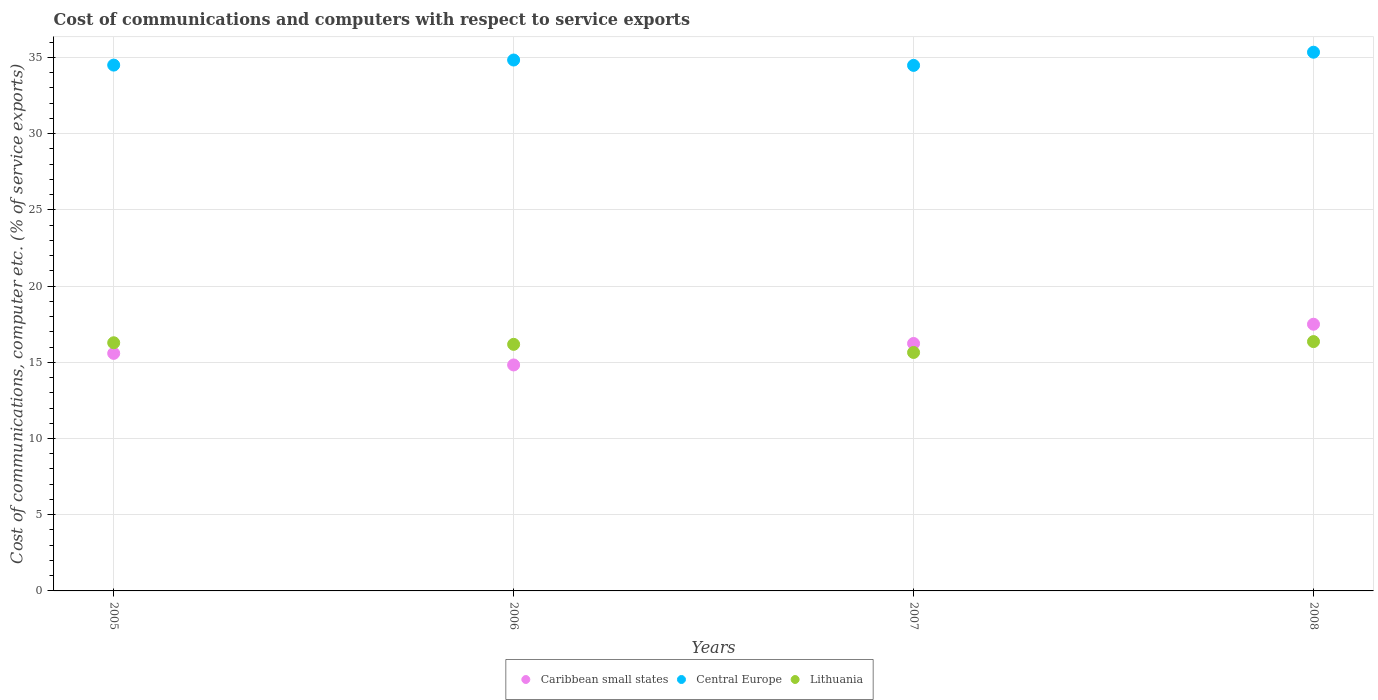How many different coloured dotlines are there?
Give a very brief answer. 3. Is the number of dotlines equal to the number of legend labels?
Offer a very short reply. Yes. What is the cost of communications and computers in Lithuania in 2005?
Offer a very short reply. 16.28. Across all years, what is the maximum cost of communications and computers in Caribbean small states?
Your answer should be very brief. 17.5. Across all years, what is the minimum cost of communications and computers in Caribbean small states?
Provide a short and direct response. 14.82. In which year was the cost of communications and computers in Caribbean small states maximum?
Provide a short and direct response. 2008. In which year was the cost of communications and computers in Central Europe minimum?
Offer a terse response. 2007. What is the total cost of communications and computers in Central Europe in the graph?
Make the answer very short. 139.14. What is the difference between the cost of communications and computers in Central Europe in 2006 and that in 2007?
Your answer should be compact. 0.35. What is the difference between the cost of communications and computers in Caribbean small states in 2006 and the cost of communications and computers in Lithuania in 2005?
Provide a short and direct response. -1.46. What is the average cost of communications and computers in Central Europe per year?
Provide a succinct answer. 34.79. In the year 2007, what is the difference between the cost of communications and computers in Lithuania and cost of communications and computers in Central Europe?
Your answer should be compact. -18.83. In how many years, is the cost of communications and computers in Caribbean small states greater than 30 %?
Your answer should be compact. 0. What is the ratio of the cost of communications and computers in Lithuania in 2006 to that in 2007?
Keep it short and to the point. 1.03. Is the cost of communications and computers in Central Europe in 2005 less than that in 2006?
Offer a very short reply. Yes. Is the difference between the cost of communications and computers in Lithuania in 2007 and 2008 greater than the difference between the cost of communications and computers in Central Europe in 2007 and 2008?
Provide a succinct answer. Yes. What is the difference between the highest and the second highest cost of communications and computers in Central Europe?
Keep it short and to the point. 0.51. What is the difference between the highest and the lowest cost of communications and computers in Caribbean small states?
Your response must be concise. 2.67. In how many years, is the cost of communications and computers in Central Europe greater than the average cost of communications and computers in Central Europe taken over all years?
Make the answer very short. 2. Is the cost of communications and computers in Lithuania strictly greater than the cost of communications and computers in Central Europe over the years?
Your answer should be very brief. No. How many dotlines are there?
Your response must be concise. 3. How many years are there in the graph?
Make the answer very short. 4. Does the graph contain any zero values?
Your answer should be compact. No. Does the graph contain grids?
Keep it short and to the point. Yes. What is the title of the graph?
Provide a short and direct response. Cost of communications and computers with respect to service exports. Does "Chad" appear as one of the legend labels in the graph?
Provide a short and direct response. No. What is the label or title of the X-axis?
Provide a succinct answer. Years. What is the label or title of the Y-axis?
Your response must be concise. Cost of communications, computer etc. (% of service exports). What is the Cost of communications, computer etc. (% of service exports) in Caribbean small states in 2005?
Your answer should be compact. 15.58. What is the Cost of communications, computer etc. (% of service exports) of Central Europe in 2005?
Offer a terse response. 34.5. What is the Cost of communications, computer etc. (% of service exports) of Lithuania in 2005?
Ensure brevity in your answer.  16.28. What is the Cost of communications, computer etc. (% of service exports) of Caribbean small states in 2006?
Your answer should be compact. 14.82. What is the Cost of communications, computer etc. (% of service exports) in Central Europe in 2006?
Ensure brevity in your answer.  34.83. What is the Cost of communications, computer etc. (% of service exports) in Lithuania in 2006?
Give a very brief answer. 16.18. What is the Cost of communications, computer etc. (% of service exports) of Caribbean small states in 2007?
Your response must be concise. 16.23. What is the Cost of communications, computer etc. (% of service exports) of Central Europe in 2007?
Provide a short and direct response. 34.48. What is the Cost of communications, computer etc. (% of service exports) in Lithuania in 2007?
Offer a terse response. 15.64. What is the Cost of communications, computer etc. (% of service exports) in Caribbean small states in 2008?
Your answer should be compact. 17.5. What is the Cost of communications, computer etc. (% of service exports) in Central Europe in 2008?
Give a very brief answer. 35.34. What is the Cost of communications, computer etc. (% of service exports) in Lithuania in 2008?
Provide a short and direct response. 16.36. Across all years, what is the maximum Cost of communications, computer etc. (% of service exports) of Caribbean small states?
Provide a short and direct response. 17.5. Across all years, what is the maximum Cost of communications, computer etc. (% of service exports) of Central Europe?
Offer a terse response. 35.34. Across all years, what is the maximum Cost of communications, computer etc. (% of service exports) in Lithuania?
Provide a succinct answer. 16.36. Across all years, what is the minimum Cost of communications, computer etc. (% of service exports) in Caribbean small states?
Keep it short and to the point. 14.82. Across all years, what is the minimum Cost of communications, computer etc. (% of service exports) of Central Europe?
Your answer should be compact. 34.48. Across all years, what is the minimum Cost of communications, computer etc. (% of service exports) in Lithuania?
Your answer should be compact. 15.64. What is the total Cost of communications, computer etc. (% of service exports) of Caribbean small states in the graph?
Keep it short and to the point. 64.14. What is the total Cost of communications, computer etc. (% of service exports) in Central Europe in the graph?
Your response must be concise. 139.14. What is the total Cost of communications, computer etc. (% of service exports) of Lithuania in the graph?
Offer a terse response. 64.46. What is the difference between the Cost of communications, computer etc. (% of service exports) in Caribbean small states in 2005 and that in 2006?
Your response must be concise. 0.76. What is the difference between the Cost of communications, computer etc. (% of service exports) of Central Europe in 2005 and that in 2006?
Ensure brevity in your answer.  -0.33. What is the difference between the Cost of communications, computer etc. (% of service exports) in Lithuania in 2005 and that in 2006?
Your response must be concise. 0.1. What is the difference between the Cost of communications, computer etc. (% of service exports) in Caribbean small states in 2005 and that in 2007?
Your response must be concise. -0.65. What is the difference between the Cost of communications, computer etc. (% of service exports) in Central Europe in 2005 and that in 2007?
Provide a short and direct response. 0.02. What is the difference between the Cost of communications, computer etc. (% of service exports) of Lithuania in 2005 and that in 2007?
Your answer should be compact. 0.64. What is the difference between the Cost of communications, computer etc. (% of service exports) of Caribbean small states in 2005 and that in 2008?
Offer a very short reply. -1.91. What is the difference between the Cost of communications, computer etc. (% of service exports) of Central Europe in 2005 and that in 2008?
Your response must be concise. -0.85. What is the difference between the Cost of communications, computer etc. (% of service exports) of Lithuania in 2005 and that in 2008?
Offer a terse response. -0.08. What is the difference between the Cost of communications, computer etc. (% of service exports) of Caribbean small states in 2006 and that in 2007?
Provide a succinct answer. -1.41. What is the difference between the Cost of communications, computer etc. (% of service exports) in Central Europe in 2006 and that in 2007?
Offer a terse response. 0.35. What is the difference between the Cost of communications, computer etc. (% of service exports) of Lithuania in 2006 and that in 2007?
Offer a terse response. 0.53. What is the difference between the Cost of communications, computer etc. (% of service exports) in Caribbean small states in 2006 and that in 2008?
Make the answer very short. -2.67. What is the difference between the Cost of communications, computer etc. (% of service exports) in Central Europe in 2006 and that in 2008?
Your response must be concise. -0.51. What is the difference between the Cost of communications, computer etc. (% of service exports) of Lithuania in 2006 and that in 2008?
Your answer should be very brief. -0.18. What is the difference between the Cost of communications, computer etc. (% of service exports) of Caribbean small states in 2007 and that in 2008?
Your answer should be very brief. -1.26. What is the difference between the Cost of communications, computer etc. (% of service exports) of Central Europe in 2007 and that in 2008?
Provide a short and direct response. -0.86. What is the difference between the Cost of communications, computer etc. (% of service exports) in Lithuania in 2007 and that in 2008?
Your response must be concise. -0.71. What is the difference between the Cost of communications, computer etc. (% of service exports) in Caribbean small states in 2005 and the Cost of communications, computer etc. (% of service exports) in Central Europe in 2006?
Provide a succinct answer. -19.24. What is the difference between the Cost of communications, computer etc. (% of service exports) of Caribbean small states in 2005 and the Cost of communications, computer etc. (% of service exports) of Lithuania in 2006?
Offer a terse response. -0.59. What is the difference between the Cost of communications, computer etc. (% of service exports) of Central Europe in 2005 and the Cost of communications, computer etc. (% of service exports) of Lithuania in 2006?
Your response must be concise. 18.32. What is the difference between the Cost of communications, computer etc. (% of service exports) of Caribbean small states in 2005 and the Cost of communications, computer etc. (% of service exports) of Central Europe in 2007?
Your answer should be compact. -18.89. What is the difference between the Cost of communications, computer etc. (% of service exports) in Caribbean small states in 2005 and the Cost of communications, computer etc. (% of service exports) in Lithuania in 2007?
Keep it short and to the point. -0.06. What is the difference between the Cost of communications, computer etc. (% of service exports) in Central Europe in 2005 and the Cost of communications, computer etc. (% of service exports) in Lithuania in 2007?
Ensure brevity in your answer.  18.85. What is the difference between the Cost of communications, computer etc. (% of service exports) of Caribbean small states in 2005 and the Cost of communications, computer etc. (% of service exports) of Central Europe in 2008?
Provide a succinct answer. -19.76. What is the difference between the Cost of communications, computer etc. (% of service exports) in Caribbean small states in 2005 and the Cost of communications, computer etc. (% of service exports) in Lithuania in 2008?
Make the answer very short. -0.77. What is the difference between the Cost of communications, computer etc. (% of service exports) of Central Europe in 2005 and the Cost of communications, computer etc. (% of service exports) of Lithuania in 2008?
Keep it short and to the point. 18.14. What is the difference between the Cost of communications, computer etc. (% of service exports) of Caribbean small states in 2006 and the Cost of communications, computer etc. (% of service exports) of Central Europe in 2007?
Ensure brevity in your answer.  -19.65. What is the difference between the Cost of communications, computer etc. (% of service exports) in Caribbean small states in 2006 and the Cost of communications, computer etc. (% of service exports) in Lithuania in 2007?
Your answer should be compact. -0.82. What is the difference between the Cost of communications, computer etc. (% of service exports) in Central Europe in 2006 and the Cost of communications, computer etc. (% of service exports) in Lithuania in 2007?
Your answer should be compact. 19.19. What is the difference between the Cost of communications, computer etc. (% of service exports) in Caribbean small states in 2006 and the Cost of communications, computer etc. (% of service exports) in Central Europe in 2008?
Your response must be concise. -20.52. What is the difference between the Cost of communications, computer etc. (% of service exports) of Caribbean small states in 2006 and the Cost of communications, computer etc. (% of service exports) of Lithuania in 2008?
Provide a succinct answer. -1.53. What is the difference between the Cost of communications, computer etc. (% of service exports) in Central Europe in 2006 and the Cost of communications, computer etc. (% of service exports) in Lithuania in 2008?
Offer a terse response. 18.47. What is the difference between the Cost of communications, computer etc. (% of service exports) in Caribbean small states in 2007 and the Cost of communications, computer etc. (% of service exports) in Central Europe in 2008?
Offer a terse response. -19.11. What is the difference between the Cost of communications, computer etc. (% of service exports) of Caribbean small states in 2007 and the Cost of communications, computer etc. (% of service exports) of Lithuania in 2008?
Ensure brevity in your answer.  -0.12. What is the difference between the Cost of communications, computer etc. (% of service exports) of Central Europe in 2007 and the Cost of communications, computer etc. (% of service exports) of Lithuania in 2008?
Your response must be concise. 18.12. What is the average Cost of communications, computer etc. (% of service exports) in Caribbean small states per year?
Offer a very short reply. 16.03. What is the average Cost of communications, computer etc. (% of service exports) in Central Europe per year?
Your answer should be very brief. 34.79. What is the average Cost of communications, computer etc. (% of service exports) in Lithuania per year?
Make the answer very short. 16.11. In the year 2005, what is the difference between the Cost of communications, computer etc. (% of service exports) in Caribbean small states and Cost of communications, computer etc. (% of service exports) in Central Europe?
Give a very brief answer. -18.91. In the year 2005, what is the difference between the Cost of communications, computer etc. (% of service exports) in Caribbean small states and Cost of communications, computer etc. (% of service exports) in Lithuania?
Provide a short and direct response. -0.7. In the year 2005, what is the difference between the Cost of communications, computer etc. (% of service exports) in Central Europe and Cost of communications, computer etc. (% of service exports) in Lithuania?
Offer a very short reply. 18.22. In the year 2006, what is the difference between the Cost of communications, computer etc. (% of service exports) in Caribbean small states and Cost of communications, computer etc. (% of service exports) in Central Europe?
Give a very brief answer. -20. In the year 2006, what is the difference between the Cost of communications, computer etc. (% of service exports) in Caribbean small states and Cost of communications, computer etc. (% of service exports) in Lithuania?
Give a very brief answer. -1.35. In the year 2006, what is the difference between the Cost of communications, computer etc. (% of service exports) in Central Europe and Cost of communications, computer etc. (% of service exports) in Lithuania?
Keep it short and to the point. 18.65. In the year 2007, what is the difference between the Cost of communications, computer etc. (% of service exports) of Caribbean small states and Cost of communications, computer etc. (% of service exports) of Central Europe?
Offer a very short reply. -18.24. In the year 2007, what is the difference between the Cost of communications, computer etc. (% of service exports) of Caribbean small states and Cost of communications, computer etc. (% of service exports) of Lithuania?
Make the answer very short. 0.59. In the year 2007, what is the difference between the Cost of communications, computer etc. (% of service exports) of Central Europe and Cost of communications, computer etc. (% of service exports) of Lithuania?
Provide a succinct answer. 18.83. In the year 2008, what is the difference between the Cost of communications, computer etc. (% of service exports) in Caribbean small states and Cost of communications, computer etc. (% of service exports) in Central Europe?
Provide a succinct answer. -17.84. In the year 2008, what is the difference between the Cost of communications, computer etc. (% of service exports) of Caribbean small states and Cost of communications, computer etc. (% of service exports) of Lithuania?
Your response must be concise. 1.14. In the year 2008, what is the difference between the Cost of communications, computer etc. (% of service exports) in Central Europe and Cost of communications, computer etc. (% of service exports) in Lithuania?
Provide a succinct answer. 18.98. What is the ratio of the Cost of communications, computer etc. (% of service exports) of Caribbean small states in 2005 to that in 2006?
Provide a succinct answer. 1.05. What is the ratio of the Cost of communications, computer etc. (% of service exports) in Central Europe in 2005 to that in 2006?
Your response must be concise. 0.99. What is the ratio of the Cost of communications, computer etc. (% of service exports) in Lithuania in 2005 to that in 2006?
Keep it short and to the point. 1.01. What is the ratio of the Cost of communications, computer etc. (% of service exports) of Caribbean small states in 2005 to that in 2007?
Your response must be concise. 0.96. What is the ratio of the Cost of communications, computer etc. (% of service exports) in Central Europe in 2005 to that in 2007?
Ensure brevity in your answer.  1. What is the ratio of the Cost of communications, computer etc. (% of service exports) in Lithuania in 2005 to that in 2007?
Offer a very short reply. 1.04. What is the ratio of the Cost of communications, computer etc. (% of service exports) in Caribbean small states in 2005 to that in 2008?
Your answer should be very brief. 0.89. What is the ratio of the Cost of communications, computer etc. (% of service exports) in Central Europe in 2005 to that in 2008?
Provide a succinct answer. 0.98. What is the ratio of the Cost of communications, computer etc. (% of service exports) in Lithuania in 2005 to that in 2008?
Keep it short and to the point. 1. What is the ratio of the Cost of communications, computer etc. (% of service exports) in Caribbean small states in 2006 to that in 2007?
Provide a succinct answer. 0.91. What is the ratio of the Cost of communications, computer etc. (% of service exports) of Central Europe in 2006 to that in 2007?
Your answer should be compact. 1.01. What is the ratio of the Cost of communications, computer etc. (% of service exports) in Lithuania in 2006 to that in 2007?
Your response must be concise. 1.03. What is the ratio of the Cost of communications, computer etc. (% of service exports) in Caribbean small states in 2006 to that in 2008?
Keep it short and to the point. 0.85. What is the ratio of the Cost of communications, computer etc. (% of service exports) of Central Europe in 2006 to that in 2008?
Give a very brief answer. 0.99. What is the ratio of the Cost of communications, computer etc. (% of service exports) in Caribbean small states in 2007 to that in 2008?
Your response must be concise. 0.93. What is the ratio of the Cost of communications, computer etc. (% of service exports) of Central Europe in 2007 to that in 2008?
Offer a very short reply. 0.98. What is the ratio of the Cost of communications, computer etc. (% of service exports) in Lithuania in 2007 to that in 2008?
Ensure brevity in your answer.  0.96. What is the difference between the highest and the second highest Cost of communications, computer etc. (% of service exports) of Caribbean small states?
Your answer should be very brief. 1.26. What is the difference between the highest and the second highest Cost of communications, computer etc. (% of service exports) in Central Europe?
Your response must be concise. 0.51. What is the difference between the highest and the second highest Cost of communications, computer etc. (% of service exports) of Lithuania?
Give a very brief answer. 0.08. What is the difference between the highest and the lowest Cost of communications, computer etc. (% of service exports) in Caribbean small states?
Make the answer very short. 2.67. What is the difference between the highest and the lowest Cost of communications, computer etc. (% of service exports) in Central Europe?
Keep it short and to the point. 0.86. What is the difference between the highest and the lowest Cost of communications, computer etc. (% of service exports) of Lithuania?
Your answer should be very brief. 0.71. 